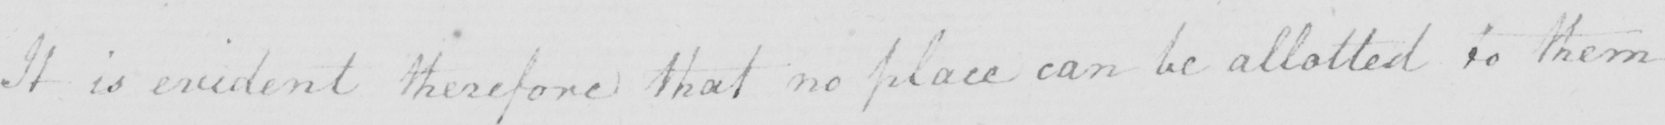Transcribe the text shown in this historical manuscript line. It is evident therefore that no place can be allotted to them 